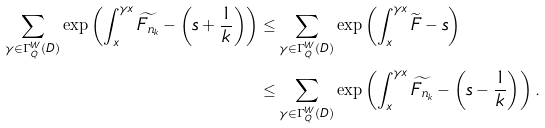<formula> <loc_0><loc_0><loc_500><loc_500>\sum _ { \gamma \in \Gamma ^ { W } _ { Q } ( D ) } \exp \left ( \int _ { x } ^ { \gamma x } \widetilde { F _ { n _ { k } } } - \left ( s + \frac { 1 } { k } \right ) \right ) & \leq \sum _ { \gamma \in \Gamma ^ { W } _ { Q } ( D ) } \exp \left ( \int _ { x } ^ { \gamma x } \widetilde { F } - s \right ) \\ & \leq \sum _ { \gamma \in \Gamma ^ { W } _ { Q } ( D ) } \exp \left ( \int _ { x } ^ { \gamma x } \widetilde { F _ { n _ { k } } } - \left ( s - \frac { 1 } { k } \right ) \right ) .</formula> 